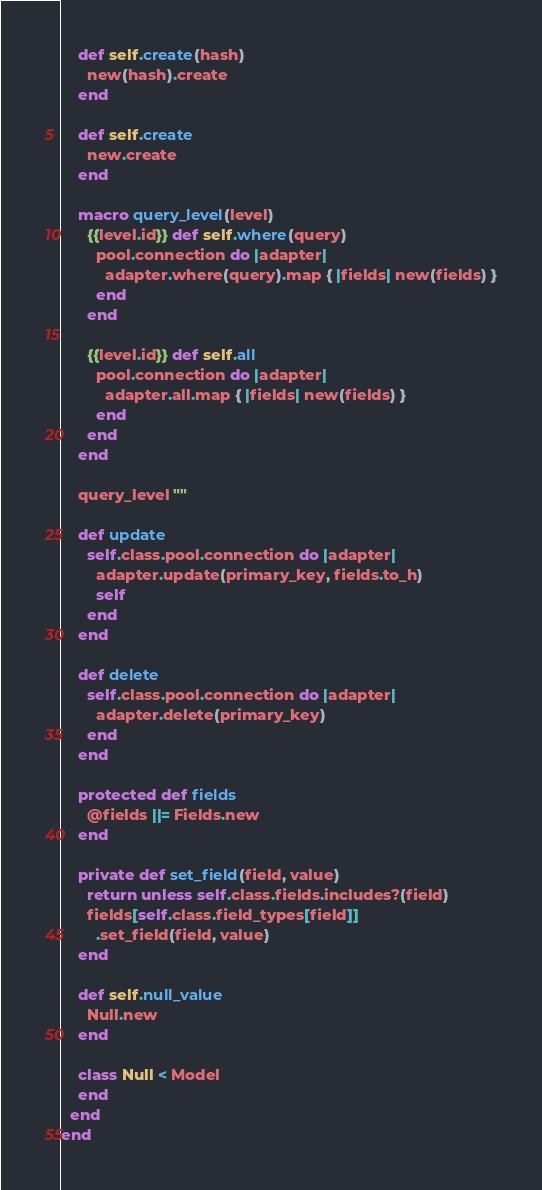Convert code to text. <code><loc_0><loc_0><loc_500><loc_500><_Crystal_>
    def self.create(hash)
      new(hash).create
    end

    def self.create
      new.create
    end

    macro query_level(level)
      {{level.id}} def self.where(query)
        pool.connection do |adapter|
          adapter.where(query).map { |fields| new(fields) }
        end
      end

      {{level.id}} def self.all
        pool.connection do |adapter|
          adapter.all.map { |fields| new(fields) }
        end
      end
    end

    query_level ""

    def update
      self.class.pool.connection do |adapter|
        adapter.update(primary_key, fields.to_h)
        self
      end
    end

    def delete
      self.class.pool.connection do |adapter|
        adapter.delete(primary_key)
      end
    end

    protected def fields
      @fields ||= Fields.new
    end

    private def set_field(field, value)
      return unless self.class.fields.includes?(field)
      fields[self.class.field_types[field]]
        .set_field(field, value)
    end

    def self.null_value
      Null.new
    end

    class Null < Model
    end
  end
end
</code> 